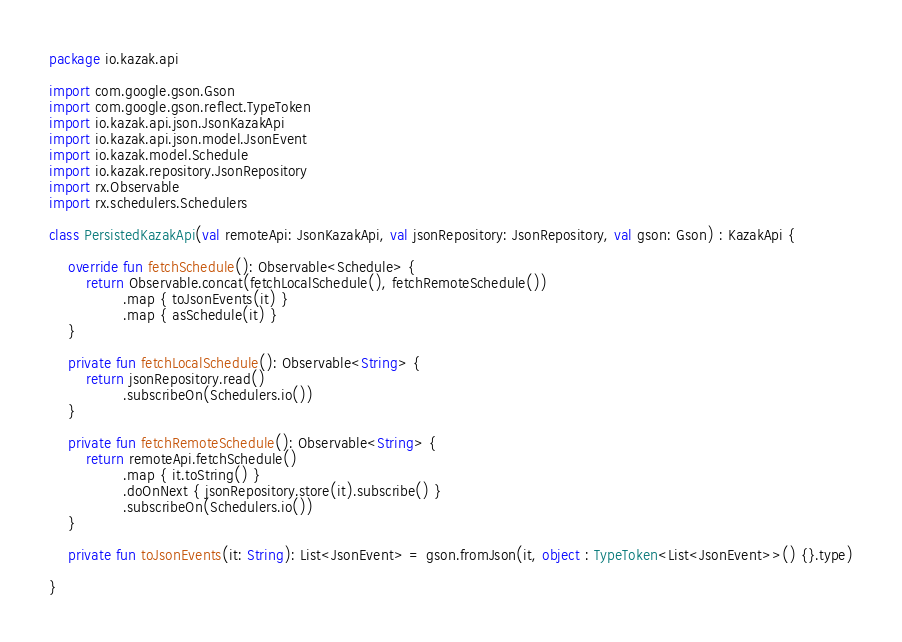Convert code to text. <code><loc_0><loc_0><loc_500><loc_500><_Kotlin_>package io.kazak.api

import com.google.gson.Gson
import com.google.gson.reflect.TypeToken
import io.kazak.api.json.JsonKazakApi
import io.kazak.api.json.model.JsonEvent
import io.kazak.model.Schedule
import io.kazak.repository.JsonRepository
import rx.Observable
import rx.schedulers.Schedulers

class PersistedKazakApi(val remoteApi: JsonKazakApi, val jsonRepository: JsonRepository, val gson: Gson) : KazakApi {

    override fun fetchSchedule(): Observable<Schedule> {
        return Observable.concat(fetchLocalSchedule(), fetchRemoteSchedule())
                .map { toJsonEvents(it) }
                .map { asSchedule(it) }
    }

    private fun fetchLocalSchedule(): Observable<String> {
        return jsonRepository.read()
                .subscribeOn(Schedulers.io())
    }

    private fun fetchRemoteSchedule(): Observable<String> {
        return remoteApi.fetchSchedule()
                .map { it.toString() }
                .doOnNext { jsonRepository.store(it).subscribe() }
                .subscribeOn(Schedulers.io())
    }

    private fun toJsonEvents(it: String): List<JsonEvent> = gson.fromJson(it, object : TypeToken<List<JsonEvent>>() {}.type)

}
</code> 